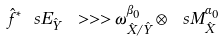Convert formula to latex. <formula><loc_0><loc_0><loc_500><loc_500>\hat { f } ^ { * } \ s E _ { \hat { Y } } \ > > > \omega _ { \hat { X } / \hat { Y } } ^ { \beta _ { 0 } } \otimes \ s M ^ { \alpha _ { 0 } } _ { \hat { X } }</formula> 